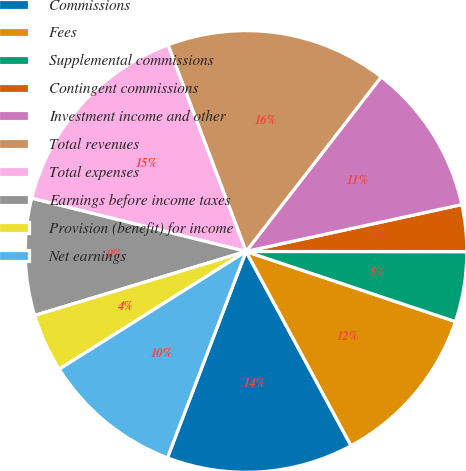<chart> <loc_0><loc_0><loc_500><loc_500><pie_chart><fcel>Commissions<fcel>Fees<fcel>Supplemental commissions<fcel>Contingent commissions<fcel>Investment income and other<fcel>Total revenues<fcel>Total expenses<fcel>Earnings before income taxes<fcel>Provision (benefit) for income<fcel>Net earnings<nl><fcel>13.68%<fcel>11.97%<fcel>5.13%<fcel>3.42%<fcel>11.11%<fcel>16.24%<fcel>15.38%<fcel>8.55%<fcel>4.27%<fcel>10.26%<nl></chart> 